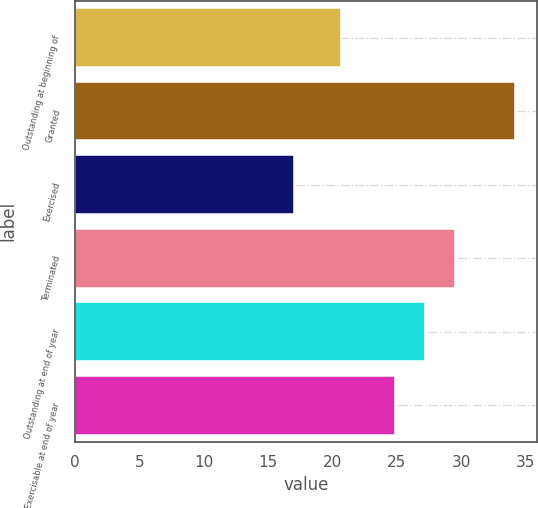Convert chart to OTSL. <chart><loc_0><loc_0><loc_500><loc_500><bar_chart><fcel>Outstanding at beginning of<fcel>Granted<fcel>Exercised<fcel>Terminated<fcel>Outstanding at end of year<fcel>Exercisable at end of year<nl><fcel>20.67<fcel>34.17<fcel>16.99<fcel>29.51<fcel>27.18<fcel>24.9<nl></chart> 